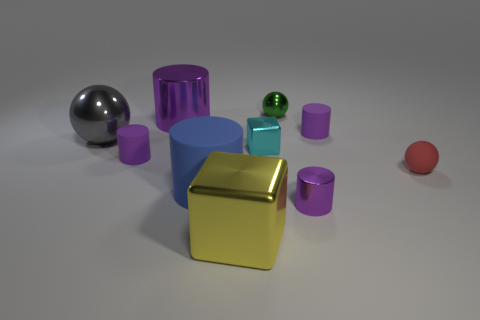Subtract all purple cylinders. How many were subtracted if there are1purple cylinders left? 3 Subtract all yellow blocks. How many purple cylinders are left? 4 Subtract all blue cylinders. How many cylinders are left? 4 Subtract all large blue matte cylinders. How many cylinders are left? 4 Subtract all red cylinders. Subtract all green balls. How many cylinders are left? 5 Subtract all blocks. How many objects are left? 8 Subtract all small metal blocks. Subtract all tiny green objects. How many objects are left? 8 Add 8 red balls. How many red balls are left? 9 Add 4 tiny metallic cubes. How many tiny metallic cubes exist? 5 Subtract 0 brown spheres. How many objects are left? 10 